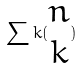<formula> <loc_0><loc_0><loc_500><loc_500>\sum k ( \begin{matrix} n \\ k \end{matrix} )</formula> 